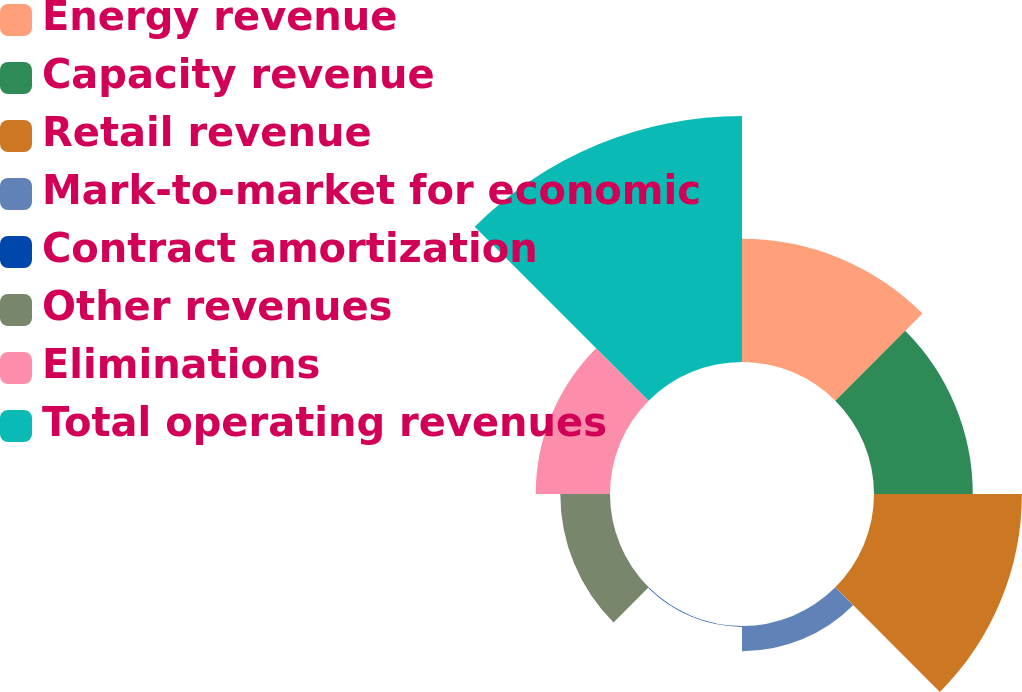Convert chart. <chart><loc_0><loc_0><loc_500><loc_500><pie_chart><fcel>Energy revenue<fcel>Capacity revenue<fcel>Retail revenue<fcel>Mark-to-market for economic<fcel>Contract amortization<fcel>Other revenues<fcel>Eliminations<fcel>Total operating revenues<nl><fcel>16.1%<fcel>12.9%<fcel>19.31%<fcel>3.29%<fcel>0.09%<fcel>6.49%<fcel>9.7%<fcel>32.12%<nl></chart> 